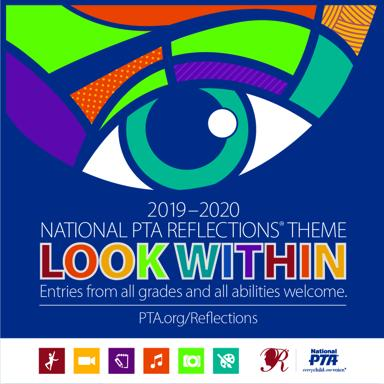Who can participate in the National PTA Reflections program? The National PTA Reflections program welcomes entries from students of all grades and abilities across multiple arts categories. The program aims to nurture artistic talent at all levels of schooling from primary through secondary education. 